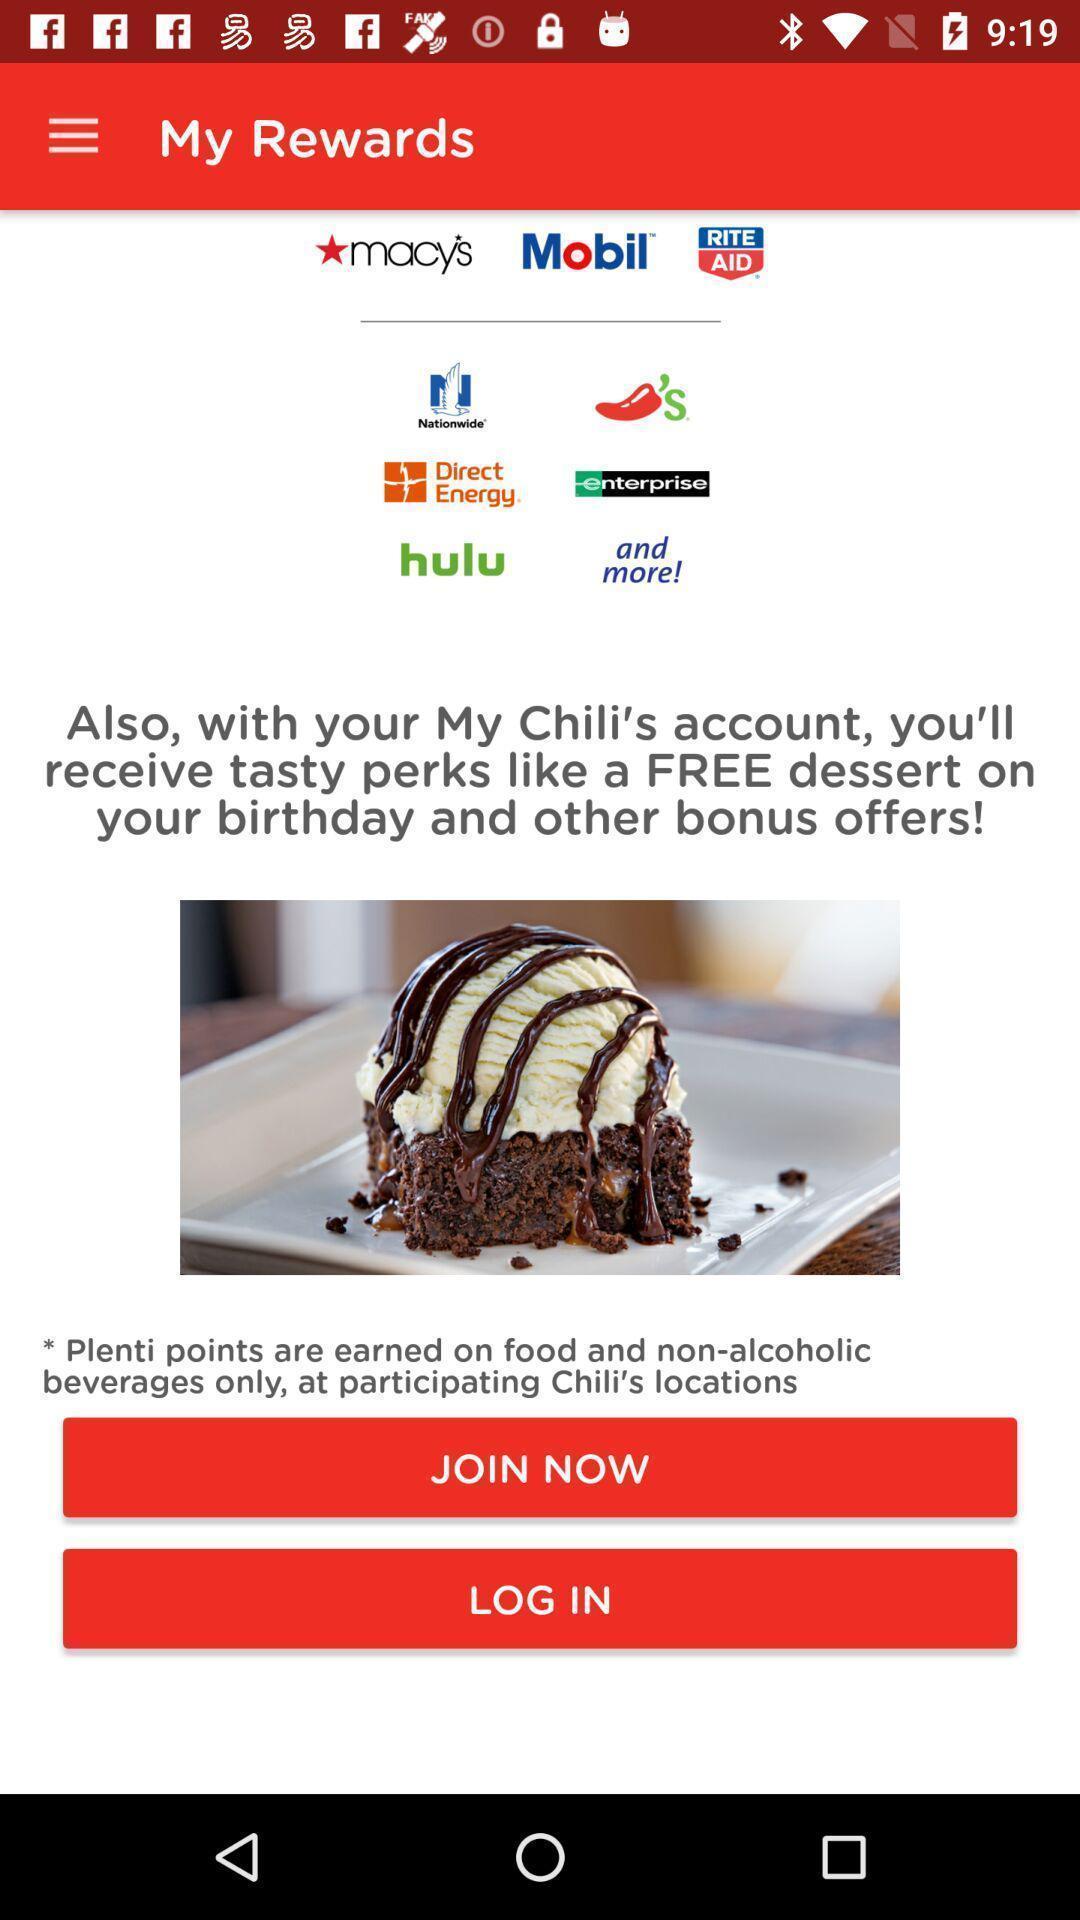Describe the content in this image. Page showing login for rewards in the app. 